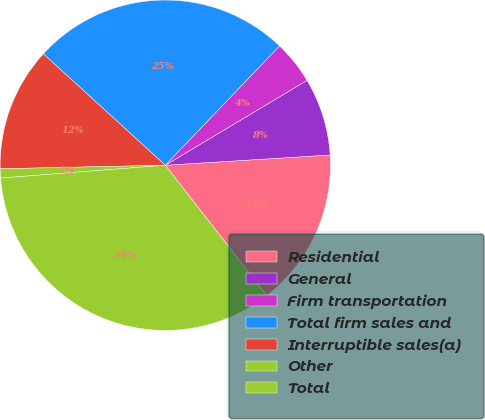Convert chart to OTSL. <chart><loc_0><loc_0><loc_500><loc_500><pie_chart><fcel>Residential<fcel>General<fcel>Firm transportation<fcel>Total firm sales and<fcel>Interruptible sales(a)<fcel>Other<fcel>Total<nl><fcel>15.46%<fcel>7.6%<fcel>4.26%<fcel>25.38%<fcel>12.12%<fcel>0.9%<fcel>34.3%<nl></chart> 